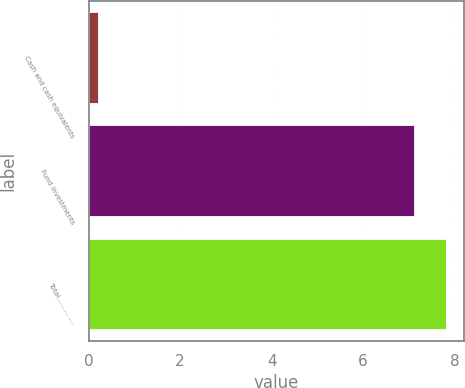Convert chart to OTSL. <chart><loc_0><loc_0><loc_500><loc_500><bar_chart><fcel>Cash and cash equivalents<fcel>Fund investments<fcel>Total……… …<nl><fcel>0.2<fcel>7.1<fcel>7.81<nl></chart> 